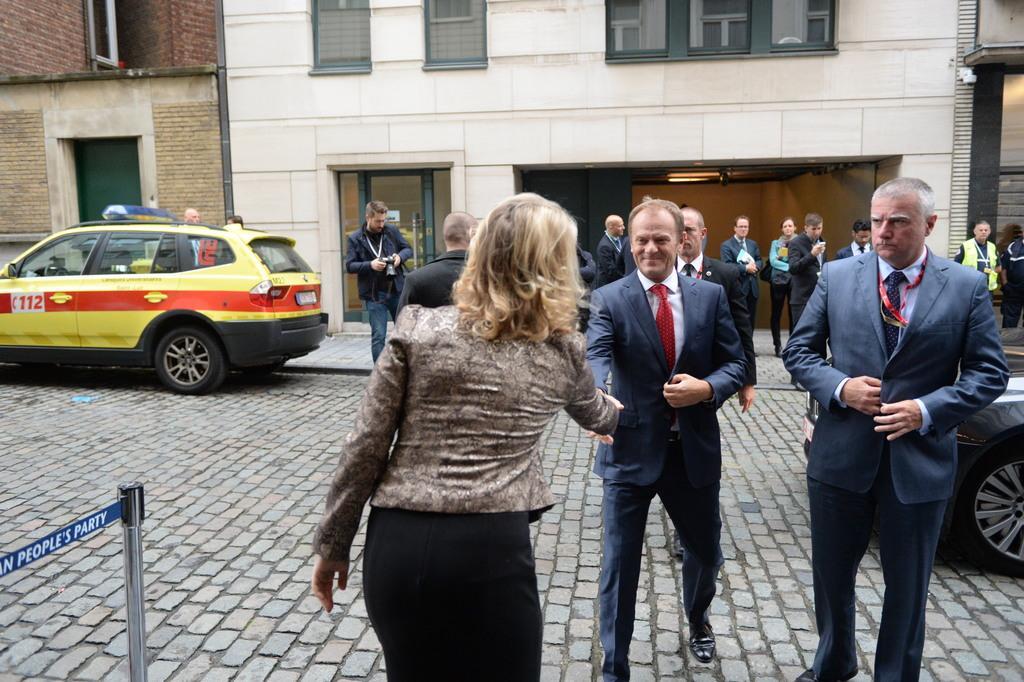Can you describe this image briefly? In this image I can see number of persons are standing on the ground. I can see two vehicles, a pole and a building in the background. I can see few windows of the building. 